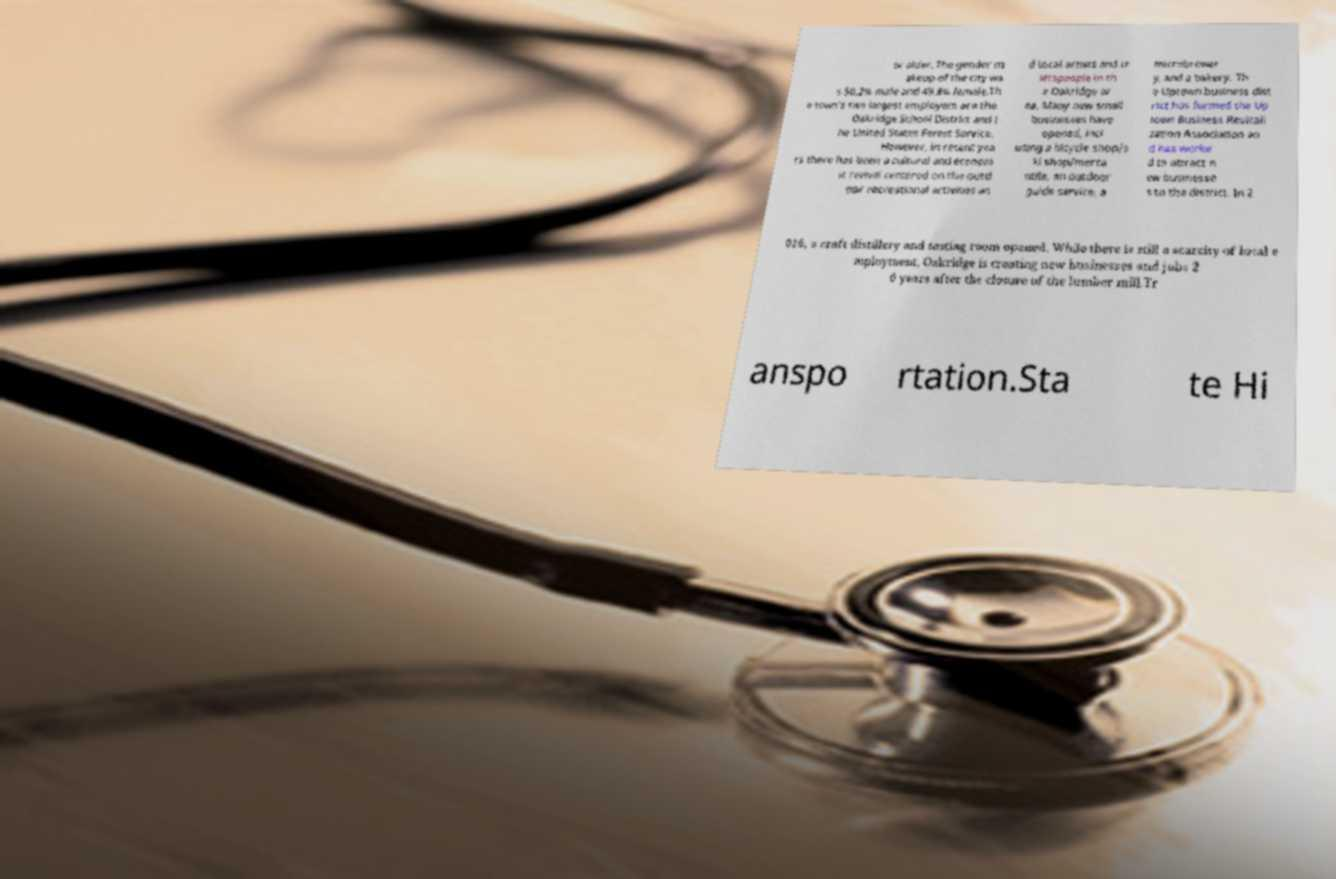Please read and relay the text visible in this image. What does it say? or older. The gender m akeup of the city wa s 50.2% male and 49.8% female.Th e town's two largest employers are the Oakridge School District and t he United States Forest Service. However, in recent yea rs there has been a cultural and econom ic revival centered on the outd oor recreational activities an d local artists and cr aftspeople in th e Oakridge ar ea. Many new small businesses have opened, incl uding a bicycle shop/s ki shop/merca ntile, an outdoor guide service, a microbrewer y, and a bakery. Th e Uptown business dist rict has formed the Up town Business Revitali zation Association an d has worke d to attract n ew businesse s to the district. In 2 016, a craft distillery and tasting room opened. While there is still a scarcity of local e mployment, Oakridge is creating new businesses and jobs 2 0 years after the closure of the lumber mill.Tr anspo rtation.Sta te Hi 